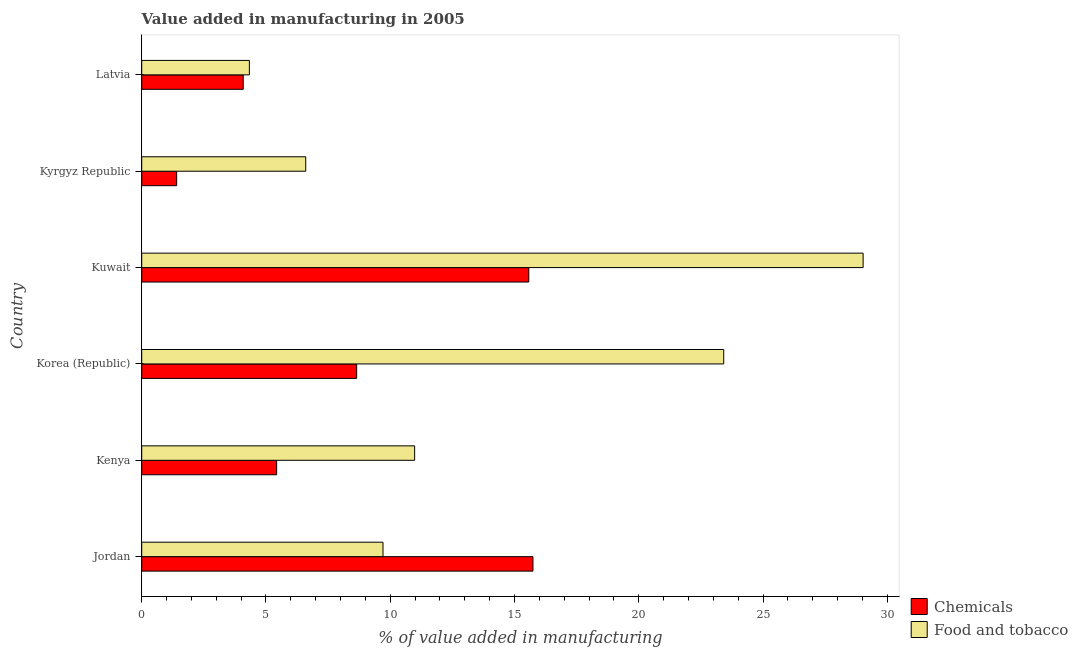How many different coloured bars are there?
Make the answer very short. 2. How many groups of bars are there?
Your answer should be compact. 6. How many bars are there on the 6th tick from the top?
Give a very brief answer. 2. How many bars are there on the 5th tick from the bottom?
Provide a short and direct response. 2. What is the label of the 4th group of bars from the top?
Give a very brief answer. Korea (Republic). In how many cases, is the number of bars for a given country not equal to the number of legend labels?
Offer a terse response. 0. What is the value added by manufacturing food and tobacco in Korea (Republic)?
Make the answer very short. 23.42. Across all countries, what is the maximum value added by manufacturing food and tobacco?
Your answer should be compact. 29.03. Across all countries, what is the minimum value added by manufacturing food and tobacco?
Keep it short and to the point. 4.33. In which country was the value added by manufacturing food and tobacco maximum?
Your answer should be compact. Kuwait. In which country was the value added by manufacturing food and tobacco minimum?
Offer a terse response. Latvia. What is the total value added by  manufacturing chemicals in the graph?
Your answer should be compact. 50.88. What is the difference between the value added by  manufacturing chemicals in Jordan and that in Latvia?
Your response must be concise. 11.66. What is the difference between the value added by manufacturing food and tobacco in Latvia and the value added by  manufacturing chemicals in Kyrgyz Republic?
Keep it short and to the point. 2.93. What is the average value added by  manufacturing chemicals per country?
Give a very brief answer. 8.48. What is the difference between the value added by manufacturing food and tobacco and value added by  manufacturing chemicals in Kenya?
Offer a very short reply. 5.55. In how many countries, is the value added by  manufacturing chemicals greater than 11 %?
Make the answer very short. 2. What is the ratio of the value added by manufacturing food and tobacco in Kuwait to that in Latvia?
Provide a short and direct response. 6.7. Is the value added by manufacturing food and tobacco in Jordan less than that in Korea (Republic)?
Provide a short and direct response. Yes. What is the difference between the highest and the second highest value added by  manufacturing chemicals?
Your response must be concise. 0.17. What is the difference between the highest and the lowest value added by  manufacturing chemicals?
Offer a terse response. 14.34. In how many countries, is the value added by  manufacturing chemicals greater than the average value added by  manufacturing chemicals taken over all countries?
Give a very brief answer. 3. Is the sum of the value added by  manufacturing chemicals in Kenya and Korea (Republic) greater than the maximum value added by manufacturing food and tobacco across all countries?
Make the answer very short. No. What does the 1st bar from the top in Kenya represents?
Offer a terse response. Food and tobacco. What does the 2nd bar from the bottom in Latvia represents?
Provide a short and direct response. Food and tobacco. Are all the bars in the graph horizontal?
Offer a very short reply. Yes. How many countries are there in the graph?
Your answer should be compact. 6. What is the difference between two consecutive major ticks on the X-axis?
Give a very brief answer. 5. Are the values on the major ticks of X-axis written in scientific E-notation?
Offer a terse response. No. How many legend labels are there?
Keep it short and to the point. 2. What is the title of the graph?
Give a very brief answer. Value added in manufacturing in 2005. What is the label or title of the X-axis?
Make the answer very short. % of value added in manufacturing. What is the % of value added in manufacturing in Chemicals in Jordan?
Your answer should be very brief. 15.74. What is the % of value added in manufacturing in Food and tobacco in Jordan?
Your answer should be very brief. 9.71. What is the % of value added in manufacturing of Chemicals in Kenya?
Provide a short and direct response. 5.43. What is the % of value added in manufacturing in Food and tobacco in Kenya?
Your response must be concise. 10.98. What is the % of value added in manufacturing in Chemicals in Korea (Republic)?
Offer a terse response. 8.65. What is the % of value added in manufacturing of Food and tobacco in Korea (Republic)?
Ensure brevity in your answer.  23.42. What is the % of value added in manufacturing of Chemicals in Kuwait?
Keep it short and to the point. 15.57. What is the % of value added in manufacturing of Food and tobacco in Kuwait?
Offer a terse response. 29.03. What is the % of value added in manufacturing in Chemicals in Kyrgyz Republic?
Your answer should be very brief. 1.41. What is the % of value added in manufacturing of Food and tobacco in Kyrgyz Republic?
Offer a very short reply. 6.6. What is the % of value added in manufacturing of Chemicals in Latvia?
Provide a short and direct response. 4.08. What is the % of value added in manufacturing of Food and tobacco in Latvia?
Make the answer very short. 4.33. Across all countries, what is the maximum % of value added in manufacturing in Chemicals?
Your answer should be very brief. 15.74. Across all countries, what is the maximum % of value added in manufacturing of Food and tobacco?
Make the answer very short. 29.03. Across all countries, what is the minimum % of value added in manufacturing in Chemicals?
Give a very brief answer. 1.41. Across all countries, what is the minimum % of value added in manufacturing of Food and tobacco?
Your response must be concise. 4.33. What is the total % of value added in manufacturing in Chemicals in the graph?
Provide a short and direct response. 50.88. What is the total % of value added in manufacturing of Food and tobacco in the graph?
Make the answer very short. 84.07. What is the difference between the % of value added in manufacturing of Chemicals in Jordan and that in Kenya?
Make the answer very short. 10.31. What is the difference between the % of value added in manufacturing in Food and tobacco in Jordan and that in Kenya?
Ensure brevity in your answer.  -1.27. What is the difference between the % of value added in manufacturing of Chemicals in Jordan and that in Korea (Republic)?
Your answer should be very brief. 7.09. What is the difference between the % of value added in manufacturing in Food and tobacco in Jordan and that in Korea (Republic)?
Give a very brief answer. -13.71. What is the difference between the % of value added in manufacturing of Chemicals in Jordan and that in Kuwait?
Provide a short and direct response. 0.17. What is the difference between the % of value added in manufacturing of Food and tobacco in Jordan and that in Kuwait?
Your response must be concise. -19.32. What is the difference between the % of value added in manufacturing of Chemicals in Jordan and that in Kyrgyz Republic?
Ensure brevity in your answer.  14.34. What is the difference between the % of value added in manufacturing in Food and tobacco in Jordan and that in Kyrgyz Republic?
Keep it short and to the point. 3.11. What is the difference between the % of value added in manufacturing of Chemicals in Jordan and that in Latvia?
Your answer should be very brief. 11.66. What is the difference between the % of value added in manufacturing in Food and tobacco in Jordan and that in Latvia?
Your response must be concise. 5.38. What is the difference between the % of value added in manufacturing of Chemicals in Kenya and that in Korea (Republic)?
Offer a very short reply. -3.22. What is the difference between the % of value added in manufacturing of Food and tobacco in Kenya and that in Korea (Republic)?
Your answer should be compact. -12.44. What is the difference between the % of value added in manufacturing in Chemicals in Kenya and that in Kuwait?
Provide a short and direct response. -10.15. What is the difference between the % of value added in manufacturing of Food and tobacco in Kenya and that in Kuwait?
Make the answer very short. -18.05. What is the difference between the % of value added in manufacturing of Chemicals in Kenya and that in Kyrgyz Republic?
Ensure brevity in your answer.  4.02. What is the difference between the % of value added in manufacturing in Food and tobacco in Kenya and that in Kyrgyz Republic?
Offer a terse response. 4.38. What is the difference between the % of value added in manufacturing in Chemicals in Kenya and that in Latvia?
Your response must be concise. 1.35. What is the difference between the % of value added in manufacturing in Food and tobacco in Kenya and that in Latvia?
Offer a very short reply. 6.65. What is the difference between the % of value added in manufacturing in Chemicals in Korea (Republic) and that in Kuwait?
Make the answer very short. -6.93. What is the difference between the % of value added in manufacturing in Food and tobacco in Korea (Republic) and that in Kuwait?
Offer a terse response. -5.61. What is the difference between the % of value added in manufacturing of Chemicals in Korea (Republic) and that in Kyrgyz Republic?
Ensure brevity in your answer.  7.24. What is the difference between the % of value added in manufacturing in Food and tobacco in Korea (Republic) and that in Kyrgyz Republic?
Give a very brief answer. 16.82. What is the difference between the % of value added in manufacturing in Chemicals in Korea (Republic) and that in Latvia?
Make the answer very short. 4.56. What is the difference between the % of value added in manufacturing of Food and tobacco in Korea (Republic) and that in Latvia?
Offer a very short reply. 19.09. What is the difference between the % of value added in manufacturing in Chemicals in Kuwait and that in Kyrgyz Republic?
Offer a very short reply. 14.17. What is the difference between the % of value added in manufacturing of Food and tobacco in Kuwait and that in Kyrgyz Republic?
Your response must be concise. 22.43. What is the difference between the % of value added in manufacturing in Chemicals in Kuwait and that in Latvia?
Make the answer very short. 11.49. What is the difference between the % of value added in manufacturing in Food and tobacco in Kuwait and that in Latvia?
Offer a terse response. 24.7. What is the difference between the % of value added in manufacturing of Chemicals in Kyrgyz Republic and that in Latvia?
Your answer should be compact. -2.68. What is the difference between the % of value added in manufacturing of Food and tobacco in Kyrgyz Republic and that in Latvia?
Provide a short and direct response. 2.27. What is the difference between the % of value added in manufacturing in Chemicals in Jordan and the % of value added in manufacturing in Food and tobacco in Kenya?
Keep it short and to the point. 4.76. What is the difference between the % of value added in manufacturing of Chemicals in Jordan and the % of value added in manufacturing of Food and tobacco in Korea (Republic)?
Make the answer very short. -7.68. What is the difference between the % of value added in manufacturing in Chemicals in Jordan and the % of value added in manufacturing in Food and tobacco in Kuwait?
Provide a succinct answer. -13.28. What is the difference between the % of value added in manufacturing of Chemicals in Jordan and the % of value added in manufacturing of Food and tobacco in Kyrgyz Republic?
Your response must be concise. 9.14. What is the difference between the % of value added in manufacturing of Chemicals in Jordan and the % of value added in manufacturing of Food and tobacco in Latvia?
Provide a short and direct response. 11.41. What is the difference between the % of value added in manufacturing of Chemicals in Kenya and the % of value added in manufacturing of Food and tobacco in Korea (Republic)?
Give a very brief answer. -17.99. What is the difference between the % of value added in manufacturing of Chemicals in Kenya and the % of value added in manufacturing of Food and tobacco in Kuwait?
Provide a short and direct response. -23.6. What is the difference between the % of value added in manufacturing in Chemicals in Kenya and the % of value added in manufacturing in Food and tobacco in Kyrgyz Republic?
Offer a terse response. -1.17. What is the difference between the % of value added in manufacturing of Chemicals in Kenya and the % of value added in manufacturing of Food and tobacco in Latvia?
Your answer should be very brief. 1.1. What is the difference between the % of value added in manufacturing in Chemicals in Korea (Republic) and the % of value added in manufacturing in Food and tobacco in Kuwait?
Provide a succinct answer. -20.38. What is the difference between the % of value added in manufacturing of Chemicals in Korea (Republic) and the % of value added in manufacturing of Food and tobacco in Kyrgyz Republic?
Give a very brief answer. 2.05. What is the difference between the % of value added in manufacturing of Chemicals in Korea (Republic) and the % of value added in manufacturing of Food and tobacco in Latvia?
Provide a succinct answer. 4.32. What is the difference between the % of value added in manufacturing of Chemicals in Kuwait and the % of value added in manufacturing of Food and tobacco in Kyrgyz Republic?
Offer a very short reply. 8.98. What is the difference between the % of value added in manufacturing in Chemicals in Kuwait and the % of value added in manufacturing in Food and tobacco in Latvia?
Provide a short and direct response. 11.24. What is the difference between the % of value added in manufacturing in Chemicals in Kyrgyz Republic and the % of value added in manufacturing in Food and tobacco in Latvia?
Provide a short and direct response. -2.93. What is the average % of value added in manufacturing in Chemicals per country?
Provide a short and direct response. 8.48. What is the average % of value added in manufacturing in Food and tobacco per country?
Provide a succinct answer. 14.01. What is the difference between the % of value added in manufacturing of Chemicals and % of value added in manufacturing of Food and tobacco in Jordan?
Your response must be concise. 6.03. What is the difference between the % of value added in manufacturing in Chemicals and % of value added in manufacturing in Food and tobacco in Kenya?
Offer a very short reply. -5.55. What is the difference between the % of value added in manufacturing in Chemicals and % of value added in manufacturing in Food and tobacco in Korea (Republic)?
Offer a terse response. -14.77. What is the difference between the % of value added in manufacturing in Chemicals and % of value added in manufacturing in Food and tobacco in Kuwait?
Give a very brief answer. -13.45. What is the difference between the % of value added in manufacturing in Chemicals and % of value added in manufacturing in Food and tobacco in Kyrgyz Republic?
Provide a short and direct response. -5.19. What is the difference between the % of value added in manufacturing in Chemicals and % of value added in manufacturing in Food and tobacco in Latvia?
Your response must be concise. -0.25. What is the ratio of the % of value added in manufacturing of Chemicals in Jordan to that in Kenya?
Ensure brevity in your answer.  2.9. What is the ratio of the % of value added in manufacturing in Food and tobacco in Jordan to that in Kenya?
Your answer should be compact. 0.88. What is the ratio of the % of value added in manufacturing in Chemicals in Jordan to that in Korea (Republic)?
Provide a succinct answer. 1.82. What is the ratio of the % of value added in manufacturing of Food and tobacco in Jordan to that in Korea (Republic)?
Provide a succinct answer. 0.41. What is the ratio of the % of value added in manufacturing in Chemicals in Jordan to that in Kuwait?
Keep it short and to the point. 1.01. What is the ratio of the % of value added in manufacturing in Food and tobacco in Jordan to that in Kuwait?
Keep it short and to the point. 0.33. What is the ratio of the % of value added in manufacturing of Chemicals in Jordan to that in Kyrgyz Republic?
Offer a terse response. 11.2. What is the ratio of the % of value added in manufacturing in Food and tobacco in Jordan to that in Kyrgyz Republic?
Your response must be concise. 1.47. What is the ratio of the % of value added in manufacturing in Chemicals in Jordan to that in Latvia?
Offer a very short reply. 3.85. What is the ratio of the % of value added in manufacturing of Food and tobacco in Jordan to that in Latvia?
Give a very brief answer. 2.24. What is the ratio of the % of value added in manufacturing in Chemicals in Kenya to that in Korea (Republic)?
Your answer should be very brief. 0.63. What is the ratio of the % of value added in manufacturing of Food and tobacco in Kenya to that in Korea (Republic)?
Keep it short and to the point. 0.47. What is the ratio of the % of value added in manufacturing in Chemicals in Kenya to that in Kuwait?
Offer a terse response. 0.35. What is the ratio of the % of value added in manufacturing of Food and tobacco in Kenya to that in Kuwait?
Provide a succinct answer. 0.38. What is the ratio of the % of value added in manufacturing in Chemicals in Kenya to that in Kyrgyz Republic?
Provide a succinct answer. 3.86. What is the ratio of the % of value added in manufacturing in Food and tobacco in Kenya to that in Kyrgyz Republic?
Ensure brevity in your answer.  1.66. What is the ratio of the % of value added in manufacturing in Chemicals in Kenya to that in Latvia?
Offer a terse response. 1.33. What is the ratio of the % of value added in manufacturing in Food and tobacco in Kenya to that in Latvia?
Your response must be concise. 2.54. What is the ratio of the % of value added in manufacturing in Chemicals in Korea (Republic) to that in Kuwait?
Give a very brief answer. 0.56. What is the ratio of the % of value added in manufacturing of Food and tobacco in Korea (Republic) to that in Kuwait?
Your response must be concise. 0.81. What is the ratio of the % of value added in manufacturing in Chemicals in Korea (Republic) to that in Kyrgyz Republic?
Keep it short and to the point. 6.15. What is the ratio of the % of value added in manufacturing of Food and tobacco in Korea (Republic) to that in Kyrgyz Republic?
Provide a short and direct response. 3.55. What is the ratio of the % of value added in manufacturing in Chemicals in Korea (Republic) to that in Latvia?
Your response must be concise. 2.12. What is the ratio of the % of value added in manufacturing of Food and tobacco in Korea (Republic) to that in Latvia?
Offer a terse response. 5.41. What is the ratio of the % of value added in manufacturing of Chemicals in Kuwait to that in Kyrgyz Republic?
Provide a short and direct response. 11.08. What is the ratio of the % of value added in manufacturing in Food and tobacco in Kuwait to that in Kyrgyz Republic?
Your answer should be compact. 4.4. What is the ratio of the % of value added in manufacturing in Chemicals in Kuwait to that in Latvia?
Your response must be concise. 3.81. What is the ratio of the % of value added in manufacturing of Food and tobacco in Kuwait to that in Latvia?
Offer a very short reply. 6.7. What is the ratio of the % of value added in manufacturing of Chemicals in Kyrgyz Republic to that in Latvia?
Make the answer very short. 0.34. What is the ratio of the % of value added in manufacturing of Food and tobacco in Kyrgyz Republic to that in Latvia?
Your answer should be very brief. 1.52. What is the difference between the highest and the second highest % of value added in manufacturing of Chemicals?
Your response must be concise. 0.17. What is the difference between the highest and the second highest % of value added in manufacturing in Food and tobacco?
Ensure brevity in your answer.  5.61. What is the difference between the highest and the lowest % of value added in manufacturing in Chemicals?
Provide a short and direct response. 14.34. What is the difference between the highest and the lowest % of value added in manufacturing in Food and tobacco?
Ensure brevity in your answer.  24.7. 